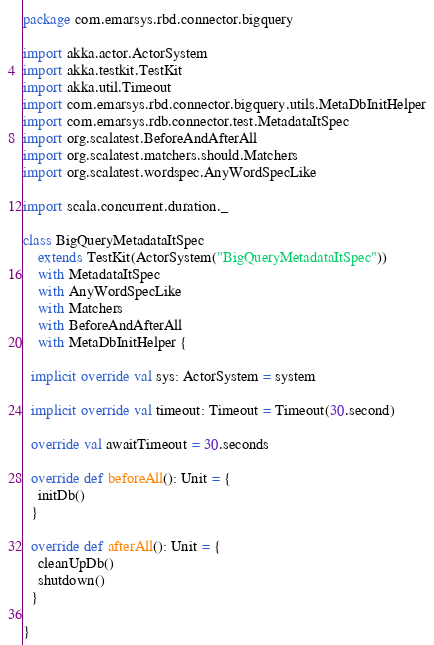<code> <loc_0><loc_0><loc_500><loc_500><_Scala_>package com.emarsys.rbd.connector.bigquery

import akka.actor.ActorSystem
import akka.testkit.TestKit
import akka.util.Timeout
import com.emarsys.rbd.connector.bigquery.utils.MetaDbInitHelper
import com.emarsys.rdb.connector.test.MetadataItSpec
import org.scalatest.BeforeAndAfterAll
import org.scalatest.matchers.should.Matchers
import org.scalatest.wordspec.AnyWordSpecLike

import scala.concurrent.duration._

class BigQueryMetadataItSpec
    extends TestKit(ActorSystem("BigQueryMetadataItSpec"))
    with MetadataItSpec
    with AnyWordSpecLike
    with Matchers
    with BeforeAndAfterAll
    with MetaDbInitHelper {

  implicit override val sys: ActorSystem = system

  implicit override val timeout: Timeout = Timeout(30.second)

  override val awaitTimeout = 30.seconds

  override def beforeAll(): Unit = {
    initDb()
  }

  override def afterAll(): Unit = {
    cleanUpDb()
    shutdown()
  }

}
</code> 